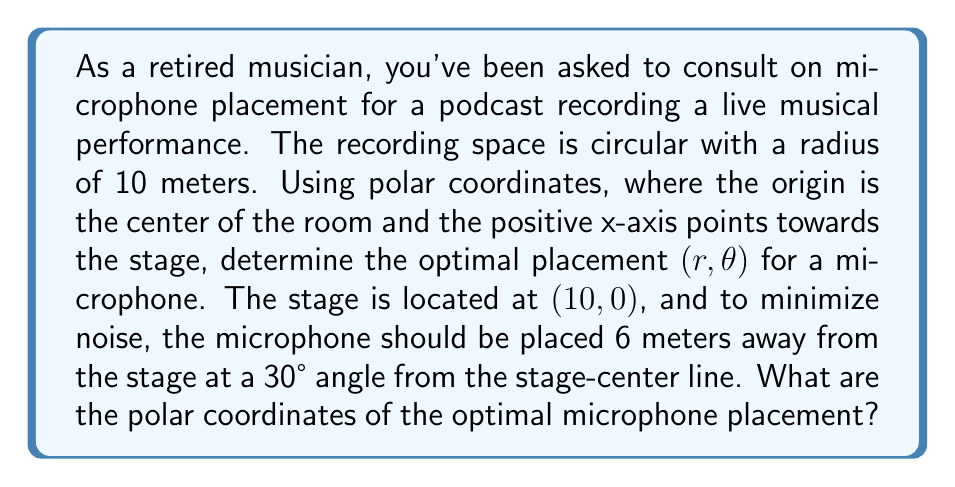Show me your answer to this math problem. To solve this problem, we'll use polar coordinates and basic trigonometry. Let's break it down step-by-step:

1) The stage is located at $(10, 0)$ in polar coordinates, which means it's on the edge of the circular room.

2) We need to place the microphone 6 meters away from the stage at a 30° angle.

3) Let's visualize this:

[asy]
import geometry;

size(200);
pair O=(0,0);
pair S=(10,0);
draw(Circle(O,10));
draw(O--S,arrow=Arrow(TeXHead));
label("Stage",S,E);
label("O",O,SW);

pair M=S+6*dir(150);
draw(S--M,dashed);
draw(O--M,arrow=Arrow(TeXHead));

label("$6m$",(S+M)/2,NW);
label("$30°$",S,N);
label("Mic",M,NE);

draw(arc(S,1,180,150),arrow=Arrow(TeXHead));
[/asy]

4) To find the polar coordinates of the microphone, we need to calculate $r$ (distance from the origin) and $\theta$ (angle from the positive x-axis).

5) We can use the law of cosines to find $r$:

   $$r^2 = 10^2 + 6^2 - 2(10)(6)\cos(150°)$$

   $$r^2 = 100 + 36 - 120\cos(150°)$$

   $$r^2 = 136 - 120(-\frac{\sqrt{3}}{2})$$

   $$r^2 = 136 + 60\sqrt{3}$$

   $$r = \sqrt{136 + 60\sqrt{3}} \approx 13.86$$

6) To find $\theta$, we can use the law of sines:

   $$\frac{\sin(30°)}{10} = \frac{\sin(\theta)}{6}$$

   $$\sin(\theta) = \frac{6\sin(30°)}{10} = \frac{3}{10}$$

   $$\theta = \arcsin(\frac{3}{10}) \approx 17.46°$$

Therefore, the optimal microphone placement in polar coordinates is approximately $(13.86, 17.46°)$.
Answer: $(r, \theta) \approx (13.86, 17.46°)$ 